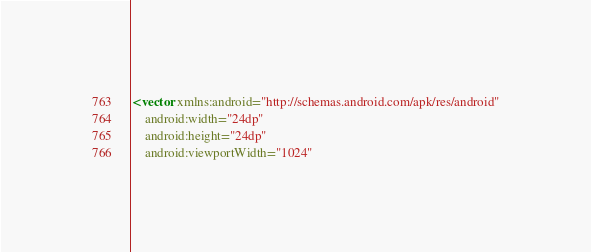Convert code to text. <code><loc_0><loc_0><loc_500><loc_500><_XML_><vector xmlns:android="http://schemas.android.com/apk/res/android"
    android:width="24dp"
    android:height="24dp"
    android:viewportWidth="1024"</code> 